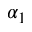Convert formula to latex. <formula><loc_0><loc_0><loc_500><loc_500>\alpha _ { 1 }</formula> 